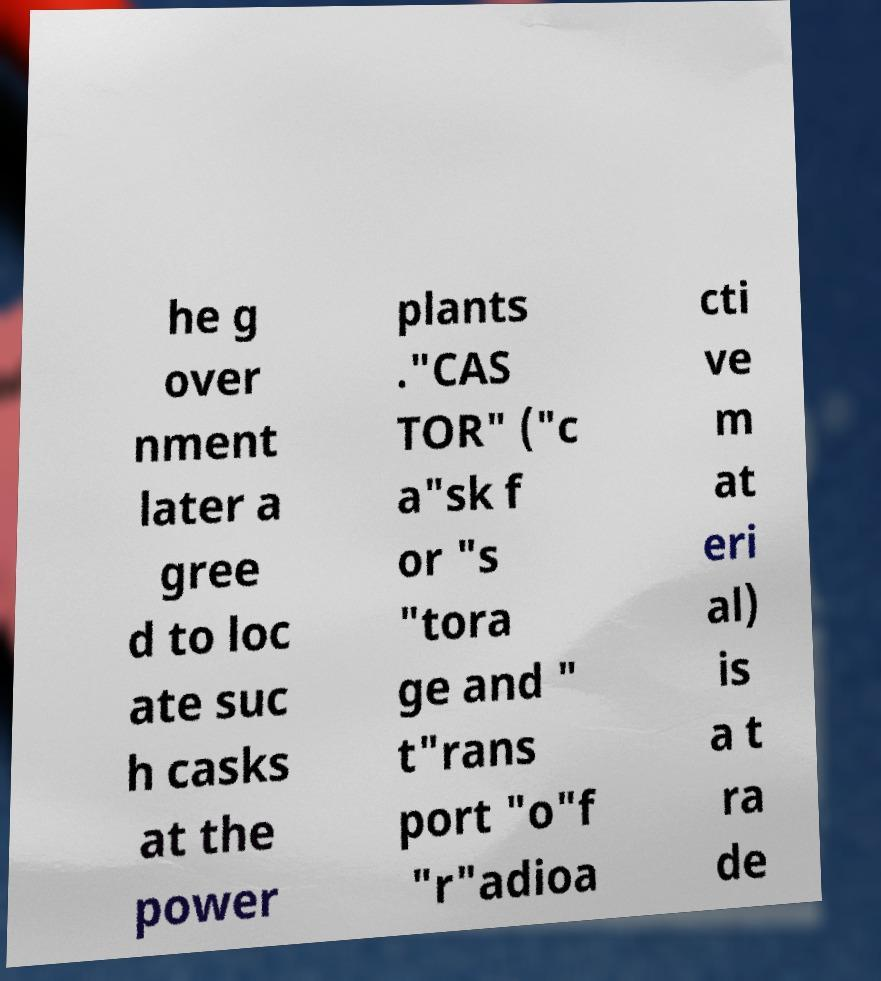Could you assist in decoding the text presented in this image and type it out clearly? he g over nment later a gree d to loc ate suc h casks at the power plants ."CAS TOR" ("c a"sk f or "s "tora ge and " t"rans port "o"f "r"adioa cti ve m at eri al) is a t ra de 